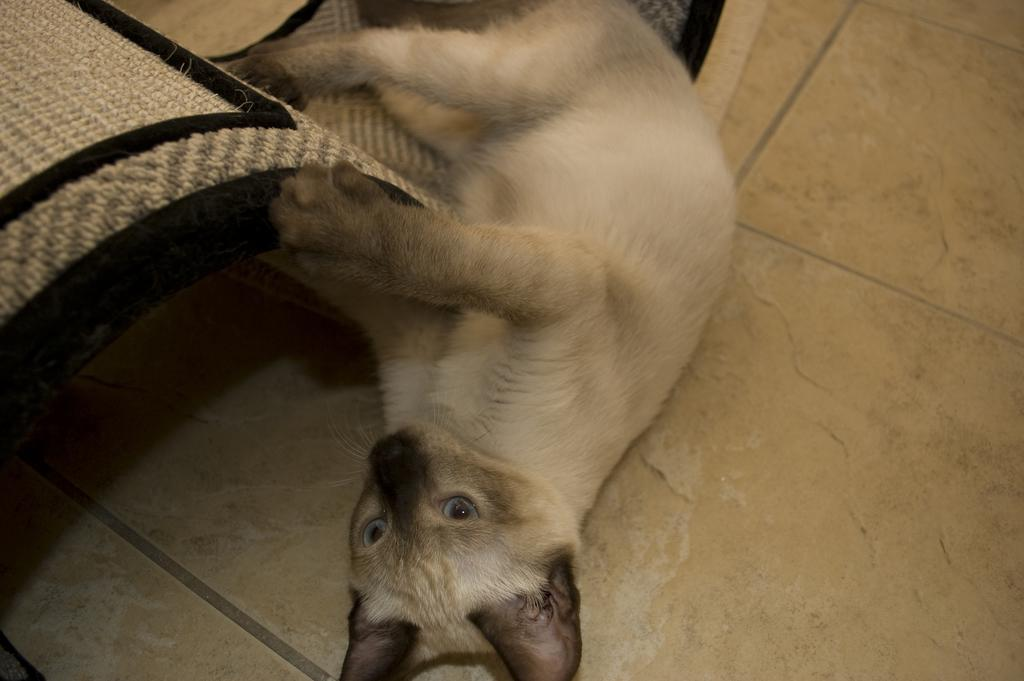What type of animal is present in the image? There is a cat in the image. What is the cat doing in the image? The cat is lying on the floor. What type of stew is the cat cooking in the image? There is no stew present in the image, as it features a cat lying on the floor. 